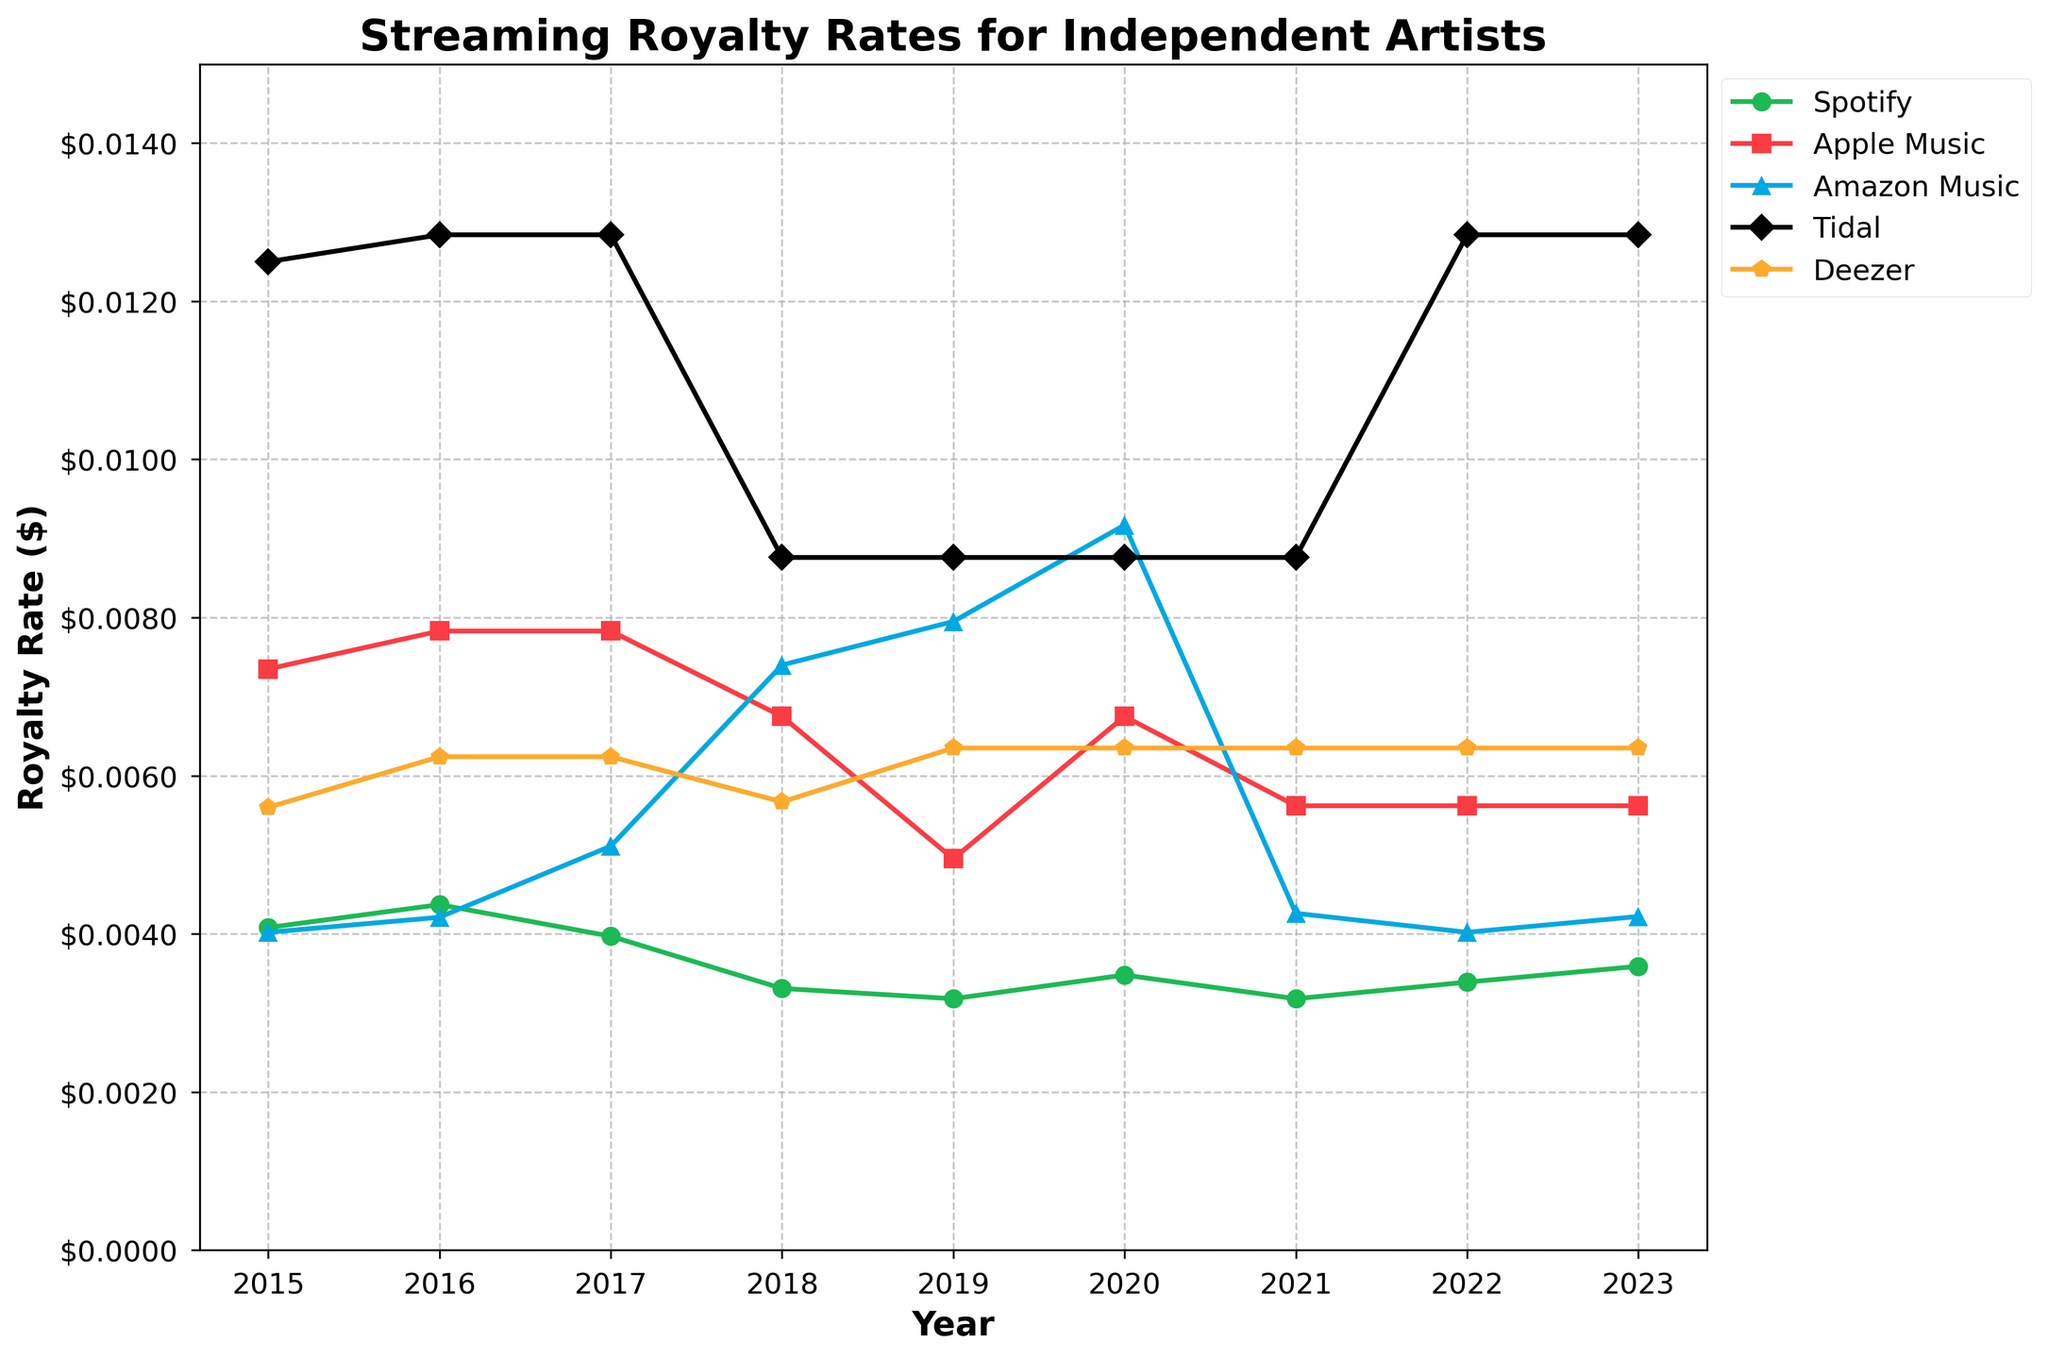What's the highest royalty rate for Tidal, and in which year did it occur? The highest point of the Tidal line will tell us the maximum royalty rate. The peak appears at 2015, 2016, 2017, 2022, and 2023 with a value of $0.01284.
Answer: $0.01284, 2015, 2016, 2017, 2022, 2023 Between 2018 and 2020, which platform had the biggest increase in royalty rates? Calculate the difference for each platform between 2018 and 2020. Amazon Music increased from $0.00740 to $0.00917, which is the largest change.
Answer: Amazon Music In what year did Deezer's royalty rate peak, and what was the rate? The highest value for Deezer is $0.00635, which occurs in 2019, 2020, 2021, 2022, and 2023.
Answer: 2019, 2020, 2021, 2022, 2023, $0.00635 Compare the royalty rates of Spotify and Apple Music in 2017. Which one was higher and by how much? In 2017, Spotify's rate was $0.00397 and Apple Music's rate was $0.00783. Apple Music is higher by the difference $0.00783 - $0.00397 = $0.00386.
Answer: Apple Music, $0.00386 Did any platform see a drop in its royalty rate from 2017 to 2018? Check each platform's values for 2017 and 2018. Spotify's rate dropped from $0.00397 to $0.00331, and Apple Music's rate dropped from $0.00783 to $0.00675.
Answer: Spotify, Apple Music What's the average royalty rate for Amazon Music across all the years shown? Sum all Amazon Music values and divide by the number of years. (0.00402+0.00421+0.00511+0.00740+0.00795+0.00917+0.00426+0.00402+0.00422) / 9 = 0.00548
Answer: $0.00548 Which platform had the most consistent (least varying) royalty rate over the years? Compare the variance or range of royalty rates for each platform. Deezer's values remain quite steady around $0.00560 to $0.00635.
Answer: Deezer 